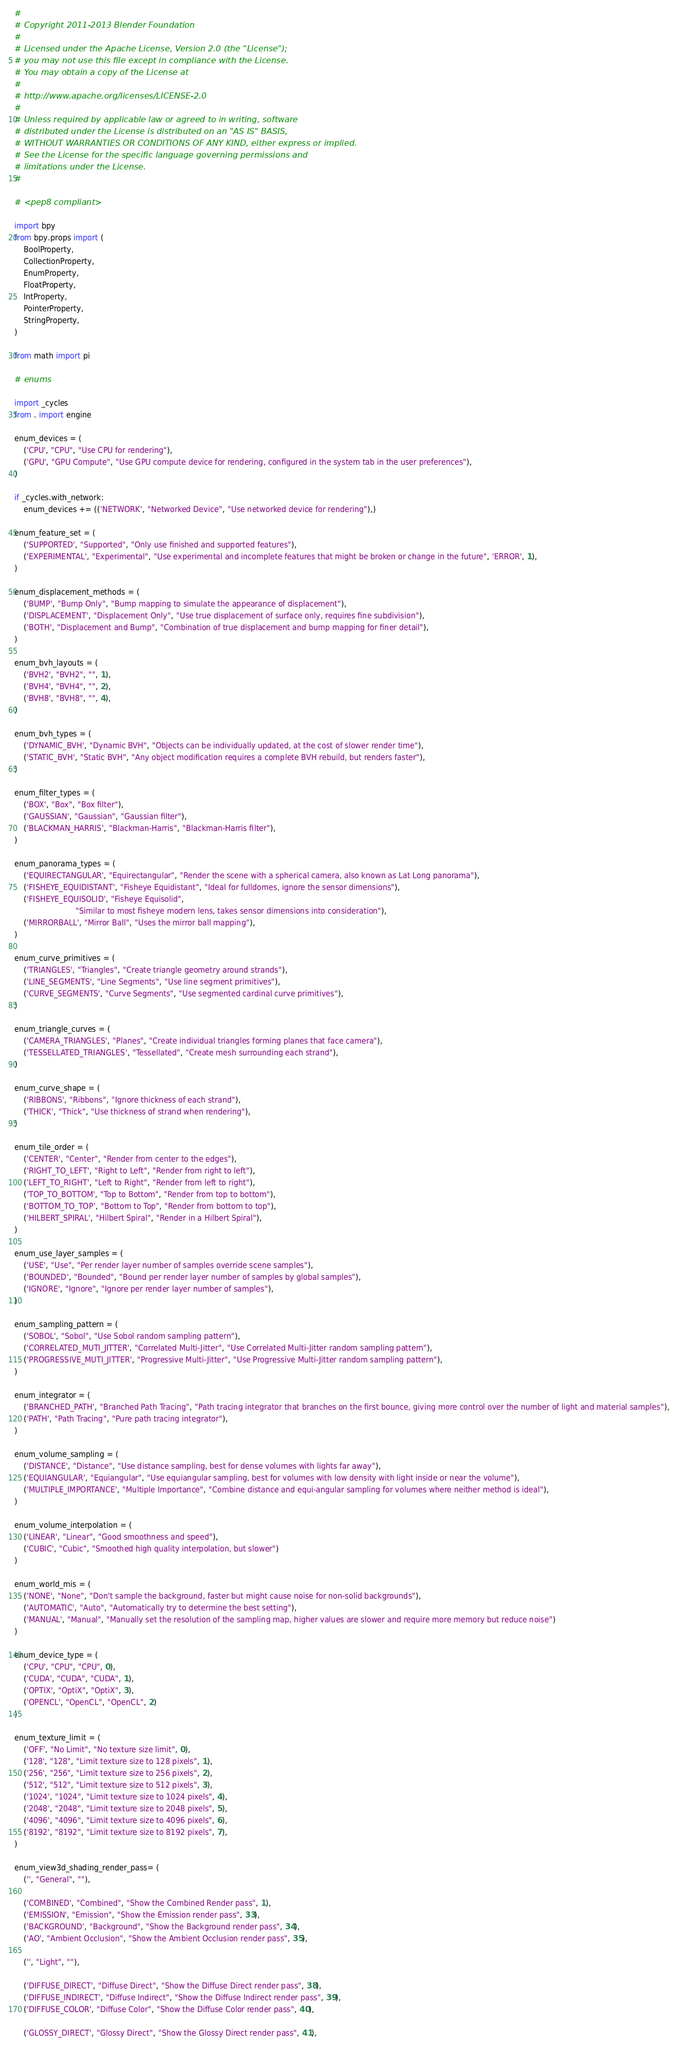Convert code to text. <code><loc_0><loc_0><loc_500><loc_500><_Python_>#
# Copyright 2011-2013 Blender Foundation
#
# Licensed under the Apache License, Version 2.0 (the "License");
# you may not use this file except in compliance with the License.
# You may obtain a copy of the License at
#
# http://www.apache.org/licenses/LICENSE-2.0
#
# Unless required by applicable law or agreed to in writing, software
# distributed under the License is distributed on an "AS IS" BASIS,
# WITHOUT WARRANTIES OR CONDITIONS OF ANY KIND, either express or implied.
# See the License for the specific language governing permissions and
# limitations under the License.
#

# <pep8 compliant>

import bpy
from bpy.props import (
    BoolProperty,
    CollectionProperty,
    EnumProperty,
    FloatProperty,
    IntProperty,
    PointerProperty,
    StringProperty,
)

from math import pi

# enums

import _cycles
from . import engine

enum_devices = (
    ('CPU', "CPU", "Use CPU for rendering"),
    ('GPU', "GPU Compute", "Use GPU compute device for rendering, configured in the system tab in the user preferences"),
)

if _cycles.with_network:
    enum_devices += (('NETWORK', "Networked Device", "Use networked device for rendering"),)

enum_feature_set = (
    ('SUPPORTED', "Supported", "Only use finished and supported features"),
    ('EXPERIMENTAL', "Experimental", "Use experimental and incomplete features that might be broken or change in the future", 'ERROR', 1),
)

enum_displacement_methods = (
    ('BUMP', "Bump Only", "Bump mapping to simulate the appearance of displacement"),
    ('DISPLACEMENT', "Displacement Only", "Use true displacement of surface only, requires fine subdivision"),
    ('BOTH', "Displacement and Bump", "Combination of true displacement and bump mapping for finer detail"),
)

enum_bvh_layouts = (
    ('BVH2', "BVH2", "", 1),
    ('BVH4', "BVH4", "", 2),
    ('BVH8', "BVH8", "", 4),
)

enum_bvh_types = (
    ('DYNAMIC_BVH', "Dynamic BVH", "Objects can be individually updated, at the cost of slower render time"),
    ('STATIC_BVH', "Static BVH", "Any object modification requires a complete BVH rebuild, but renders faster"),
)

enum_filter_types = (
    ('BOX', "Box", "Box filter"),
    ('GAUSSIAN', "Gaussian", "Gaussian filter"),
    ('BLACKMAN_HARRIS', "Blackman-Harris", "Blackman-Harris filter"),
)

enum_panorama_types = (
    ('EQUIRECTANGULAR', "Equirectangular", "Render the scene with a spherical camera, also known as Lat Long panorama"),
    ('FISHEYE_EQUIDISTANT', "Fisheye Equidistant", "Ideal for fulldomes, ignore the sensor dimensions"),
    ('FISHEYE_EQUISOLID', "Fisheye Equisolid",
                          "Similar to most fisheye modern lens, takes sensor dimensions into consideration"),
    ('MIRRORBALL', "Mirror Ball", "Uses the mirror ball mapping"),
)

enum_curve_primitives = (
    ('TRIANGLES', "Triangles", "Create triangle geometry around strands"),
    ('LINE_SEGMENTS', "Line Segments", "Use line segment primitives"),
    ('CURVE_SEGMENTS', "Curve Segments", "Use segmented cardinal curve primitives"),
)

enum_triangle_curves = (
    ('CAMERA_TRIANGLES', "Planes", "Create individual triangles forming planes that face camera"),
    ('TESSELLATED_TRIANGLES', "Tessellated", "Create mesh surrounding each strand"),
)

enum_curve_shape = (
    ('RIBBONS', "Ribbons", "Ignore thickness of each strand"),
    ('THICK', "Thick", "Use thickness of strand when rendering"),
)

enum_tile_order = (
    ('CENTER', "Center", "Render from center to the edges"),
    ('RIGHT_TO_LEFT', "Right to Left", "Render from right to left"),
    ('LEFT_TO_RIGHT', "Left to Right", "Render from left to right"),
    ('TOP_TO_BOTTOM', "Top to Bottom", "Render from top to bottom"),
    ('BOTTOM_TO_TOP', "Bottom to Top", "Render from bottom to top"),
    ('HILBERT_SPIRAL', "Hilbert Spiral", "Render in a Hilbert Spiral"),
)

enum_use_layer_samples = (
    ('USE', "Use", "Per render layer number of samples override scene samples"),
    ('BOUNDED', "Bounded", "Bound per render layer number of samples by global samples"),
    ('IGNORE', "Ignore", "Ignore per render layer number of samples"),
)

enum_sampling_pattern = (
    ('SOBOL', "Sobol", "Use Sobol random sampling pattern"),
    ('CORRELATED_MUTI_JITTER', "Correlated Multi-Jitter", "Use Correlated Multi-Jitter random sampling pattern"),
    ('PROGRESSIVE_MUTI_JITTER', "Progressive Multi-Jitter", "Use Progressive Multi-Jitter random sampling pattern"),
)

enum_integrator = (
    ('BRANCHED_PATH', "Branched Path Tracing", "Path tracing integrator that branches on the first bounce, giving more control over the number of light and material samples"),
    ('PATH', "Path Tracing", "Pure path tracing integrator"),
)

enum_volume_sampling = (
    ('DISTANCE', "Distance", "Use distance sampling, best for dense volumes with lights far away"),
    ('EQUIANGULAR', "Equiangular", "Use equiangular sampling, best for volumes with low density with light inside or near the volume"),
    ('MULTIPLE_IMPORTANCE', "Multiple Importance", "Combine distance and equi-angular sampling for volumes where neither method is ideal"),
)

enum_volume_interpolation = (
    ('LINEAR', "Linear", "Good smoothness and speed"),
    ('CUBIC', "Cubic", "Smoothed high quality interpolation, but slower")
)

enum_world_mis = (
    ('NONE', "None", "Don't sample the background, faster but might cause noise for non-solid backgrounds"),
    ('AUTOMATIC', "Auto", "Automatically try to determine the best setting"),
    ('MANUAL', "Manual", "Manually set the resolution of the sampling map, higher values are slower and require more memory but reduce noise")
)

enum_device_type = (
    ('CPU', "CPU", "CPU", 0),
    ('CUDA', "CUDA", "CUDA", 1),
    ('OPTIX', "OptiX", "OptiX", 3),
    ('OPENCL', "OpenCL", "OpenCL", 2)
)

enum_texture_limit = (
    ('OFF', "No Limit", "No texture size limit", 0),
    ('128', "128", "Limit texture size to 128 pixels", 1),
    ('256', "256", "Limit texture size to 256 pixels", 2),
    ('512', "512", "Limit texture size to 512 pixels", 3),
    ('1024', "1024", "Limit texture size to 1024 pixels", 4),
    ('2048', "2048", "Limit texture size to 2048 pixels", 5),
    ('4096', "4096", "Limit texture size to 4096 pixels", 6),
    ('8192', "8192", "Limit texture size to 8192 pixels", 7),
)

enum_view3d_shading_render_pass= (
    ('', "General", ""),

    ('COMBINED', "Combined", "Show the Combined Render pass", 1),
    ('EMISSION', "Emission", "Show the Emission render pass", 33),
    ('BACKGROUND', "Background", "Show the Background render pass", 34),
    ('AO', "Ambient Occlusion", "Show the Ambient Occlusion render pass", 35),

    ('', "Light", ""),

    ('DIFFUSE_DIRECT', "Diffuse Direct", "Show the Diffuse Direct render pass", 38),
    ('DIFFUSE_INDIRECT', "Diffuse Indirect", "Show the Diffuse Indirect render pass", 39),
    ('DIFFUSE_COLOR', "Diffuse Color", "Show the Diffuse Color render pass", 40),

    ('GLOSSY_DIRECT', "Glossy Direct", "Show the Glossy Direct render pass", 41),</code> 